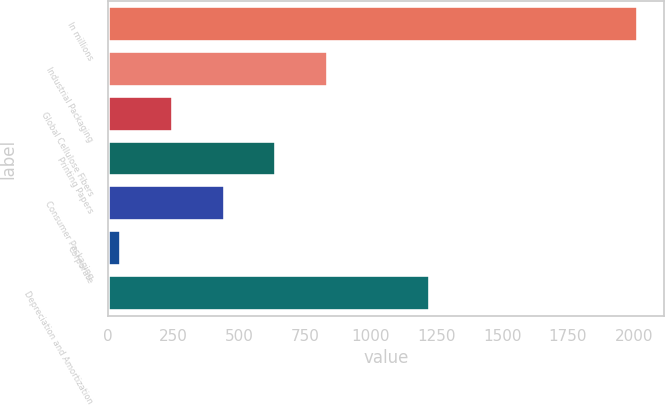Convert chart. <chart><loc_0><loc_0><loc_500><loc_500><bar_chart><fcel>In millions<fcel>Industrial Packaging<fcel>Global Cellulose Fibers<fcel>Printing Papers<fcel>Consumer Packaging<fcel>Corporate<fcel>Depreciation and Amortization<nl><fcel>2016<fcel>837<fcel>247.5<fcel>640.5<fcel>444<fcel>51<fcel>1227<nl></chart> 